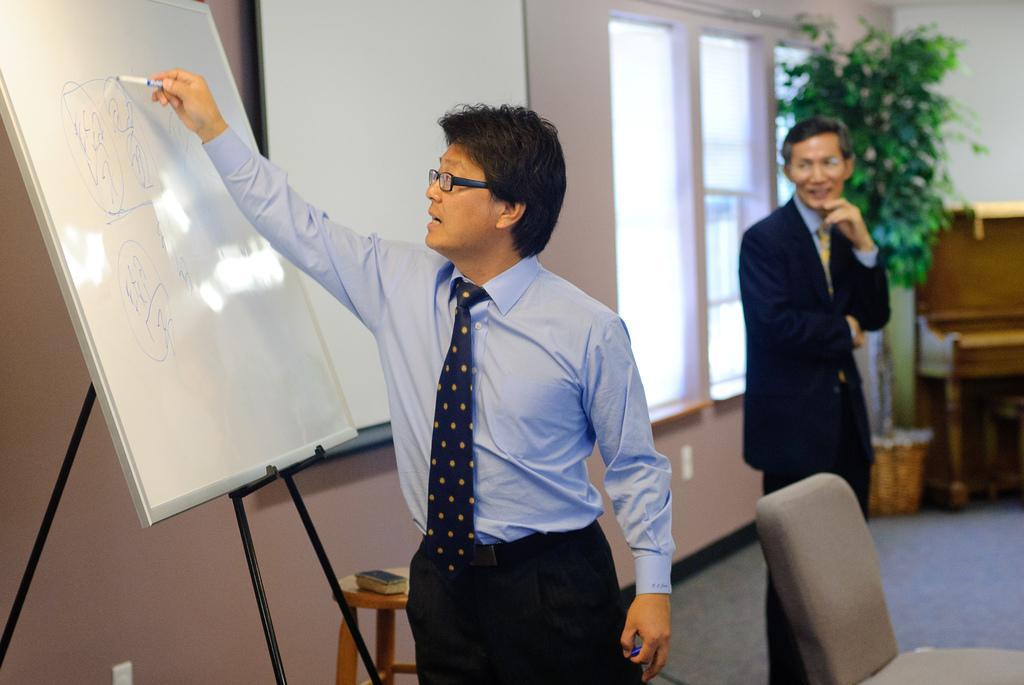Who is the main subject in the image? There is a person in the center of the image. What is the person in the center of the image doing? The person is writing on a board. Can you describe the background of the image? There is another person, a window, and a plant in the background of the image. What type of wound can be seen on the person's jeans in the image? There is no wound or jeans visible in the image; the person is wearing a long-sleeved shirt and is focused on writing on a board. 